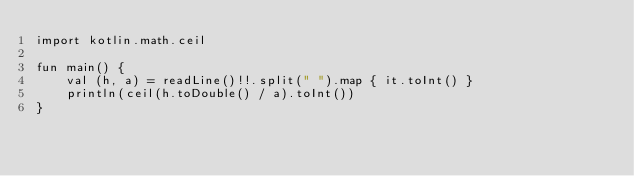Convert code to text. <code><loc_0><loc_0><loc_500><loc_500><_Kotlin_>import kotlin.math.ceil

fun main() {
    val (h, a) = readLine()!!.split(" ").map { it.toInt() }
    println(ceil(h.toDouble() / a).toInt())
}</code> 